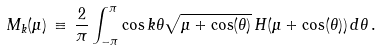<formula> <loc_0><loc_0><loc_500><loc_500>M _ { k } ( \mu ) \, \equiv \, \frac { 2 } { \pi } \int _ { - \pi } ^ { \pi } \cos { k \theta } \sqrt { \mu + \cos ( \theta ) } \, H ( \mu + \cos ( \theta ) ) \, d \theta \, .</formula> 